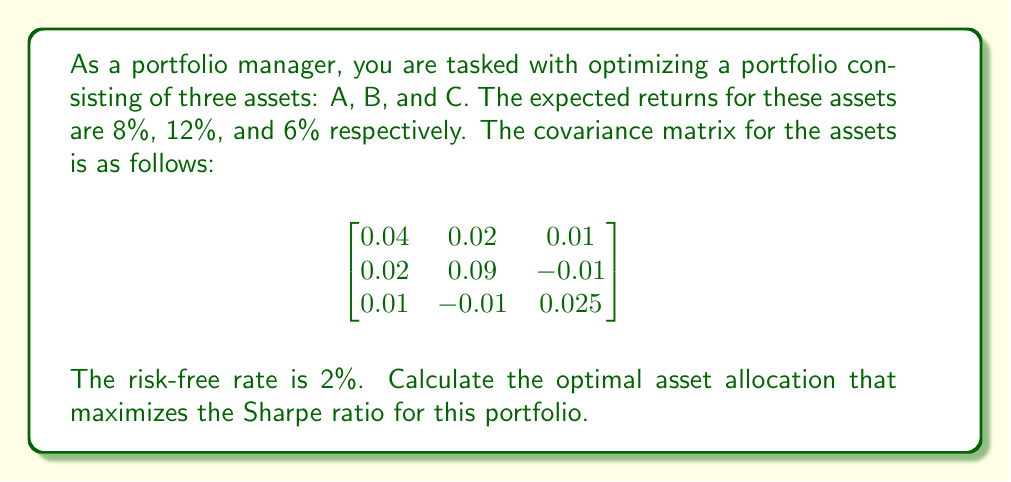Provide a solution to this math problem. To maximize the Sharpe ratio, we need to follow these steps:

1) The Sharpe ratio is defined as:

   $$ S = \frac{R_p - R_f}{\sigma_p} $$

   where $R_p$ is the portfolio return, $R_f$ is the risk-free rate, and $\sigma_p$ is the portfolio standard deviation.

2) Let $w_1$, $w_2$, and $w_3$ be the weights of assets A, B, and C respectively. We need to find these weights to maximize S.

3) The portfolio return is:

   $$ R_p = 0.08w_1 + 0.12w_2 + 0.06w_3 $$

4) The portfolio variance is:

   $$ \sigma_p^2 = w^T \Sigma w $$

   where $w$ is the weight vector and $\Sigma$ is the covariance matrix.

5) We need to maximize:

   $$ S = \frac{(0.08w_1 + 0.12w_2 + 0.06w_3) - 0.02}{\sqrt{w^T \Sigma w}} $$

6) This is a non-linear optimization problem subject to the constraint $w_1 + w_2 + w_3 = 1$.

7) Using optimization software or numerical methods, we can find that the optimal weights are approximately:

   $w_1 = 0.2776$
   $w_2 = 0.3879$
   $w_3 = 0.3345$

8) These weights result in a portfolio return of 8.83% and a portfolio standard deviation of 16.15%.

9) The maximum Sharpe ratio is:

   $$ S = \frac{0.0883 - 0.02}{0.1615} = 0.4229 $$
Answer: The optimal asset allocation that maximizes the Sharpe ratio is approximately:
Asset A: 27.76%
Asset B: 38.79%
Asset C: 33.45%

This allocation results in a maximum Sharpe ratio of 0.4229. 